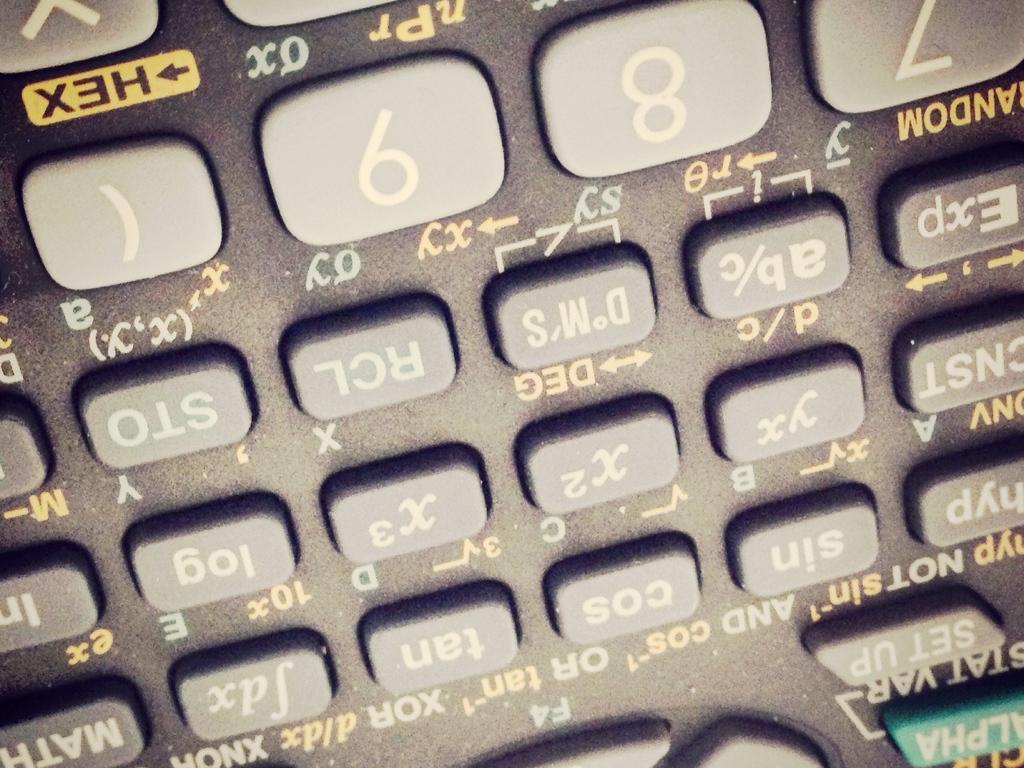Describe this image in one or two sentences. Here we can see number calculator buttons. 